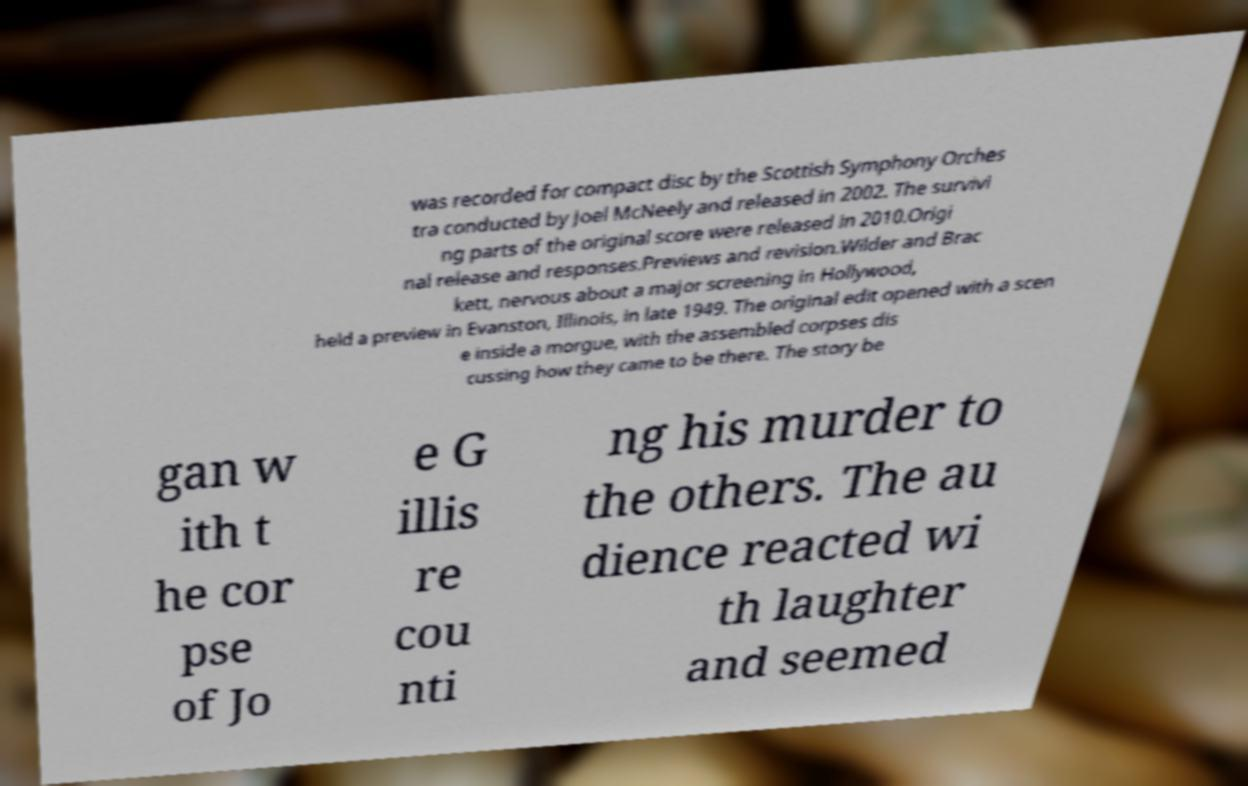Please read and relay the text visible in this image. What does it say? was recorded for compact disc by the Scottish Symphony Orches tra conducted by Joel McNeely and released in 2002. The survivi ng parts of the original score were released in 2010.Origi nal release and responses.Previews and revision.Wilder and Brac kett, nervous about a major screening in Hollywood, held a preview in Evanston, Illinois, in late 1949. The original edit opened with a scen e inside a morgue, with the assembled corpses dis cussing how they came to be there. The story be gan w ith t he cor pse of Jo e G illis re cou nti ng his murder to the others. The au dience reacted wi th laughter and seemed 